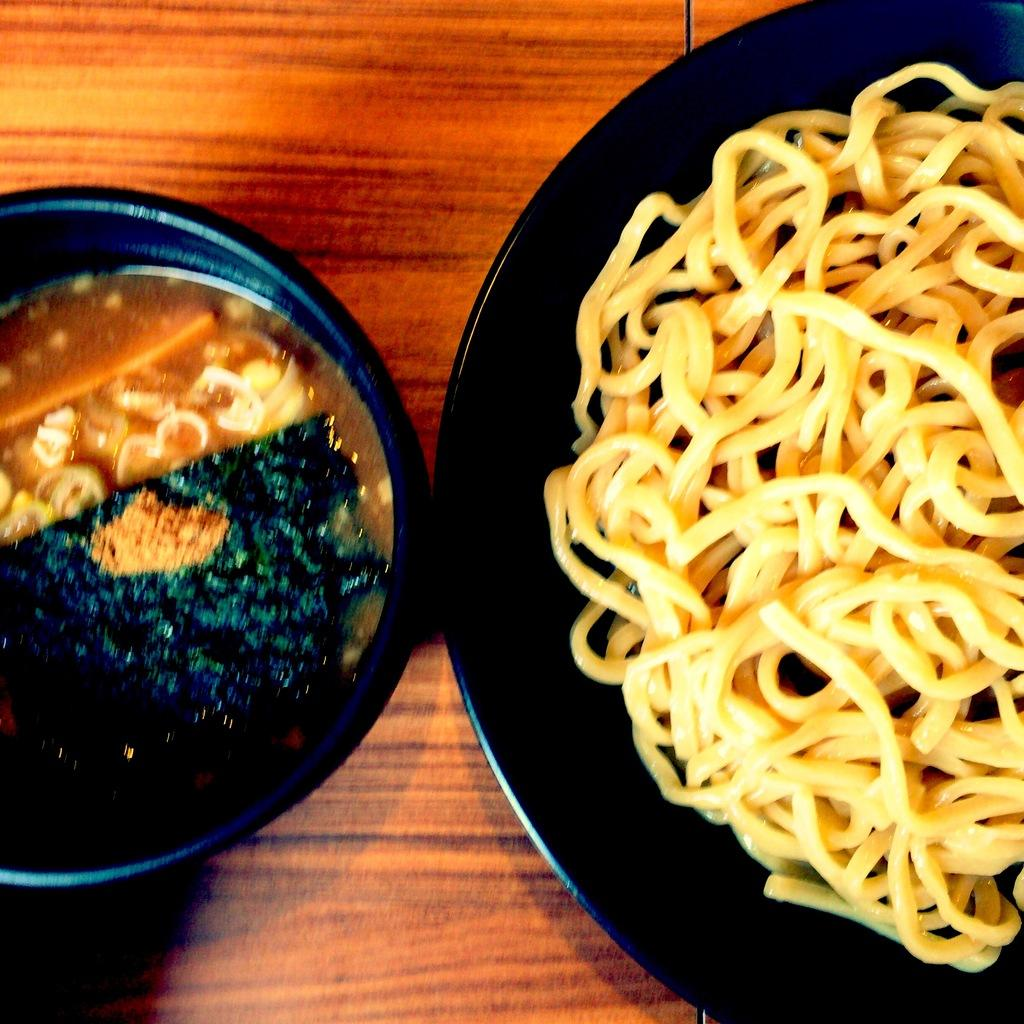What type of food is present in the image? The image contains food, but the specific type of food is not mentioned. Where is the food located in the image? The food is in the center of the image. What type of road can be seen in the image? There is no road present in the image; it only contains food. How does the pail help with the trouble in the image? There is no pail or trouble mentioned in the image, as it only contains food. 